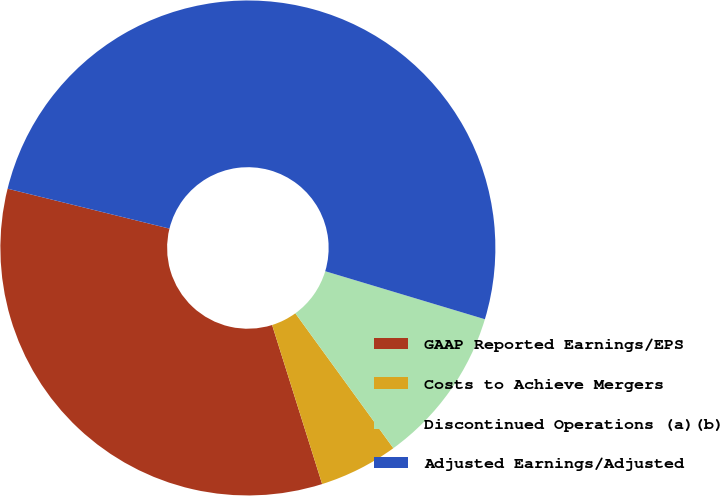Convert chart. <chart><loc_0><loc_0><loc_500><loc_500><pie_chart><fcel>GAAP Reported Earnings/EPS<fcel>Costs to Achieve Mergers<fcel>Discontinued Operations (a)(b)<fcel>Adjusted Earnings/Adjusted<nl><fcel>33.7%<fcel>5.15%<fcel>10.35%<fcel>50.8%<nl></chart> 